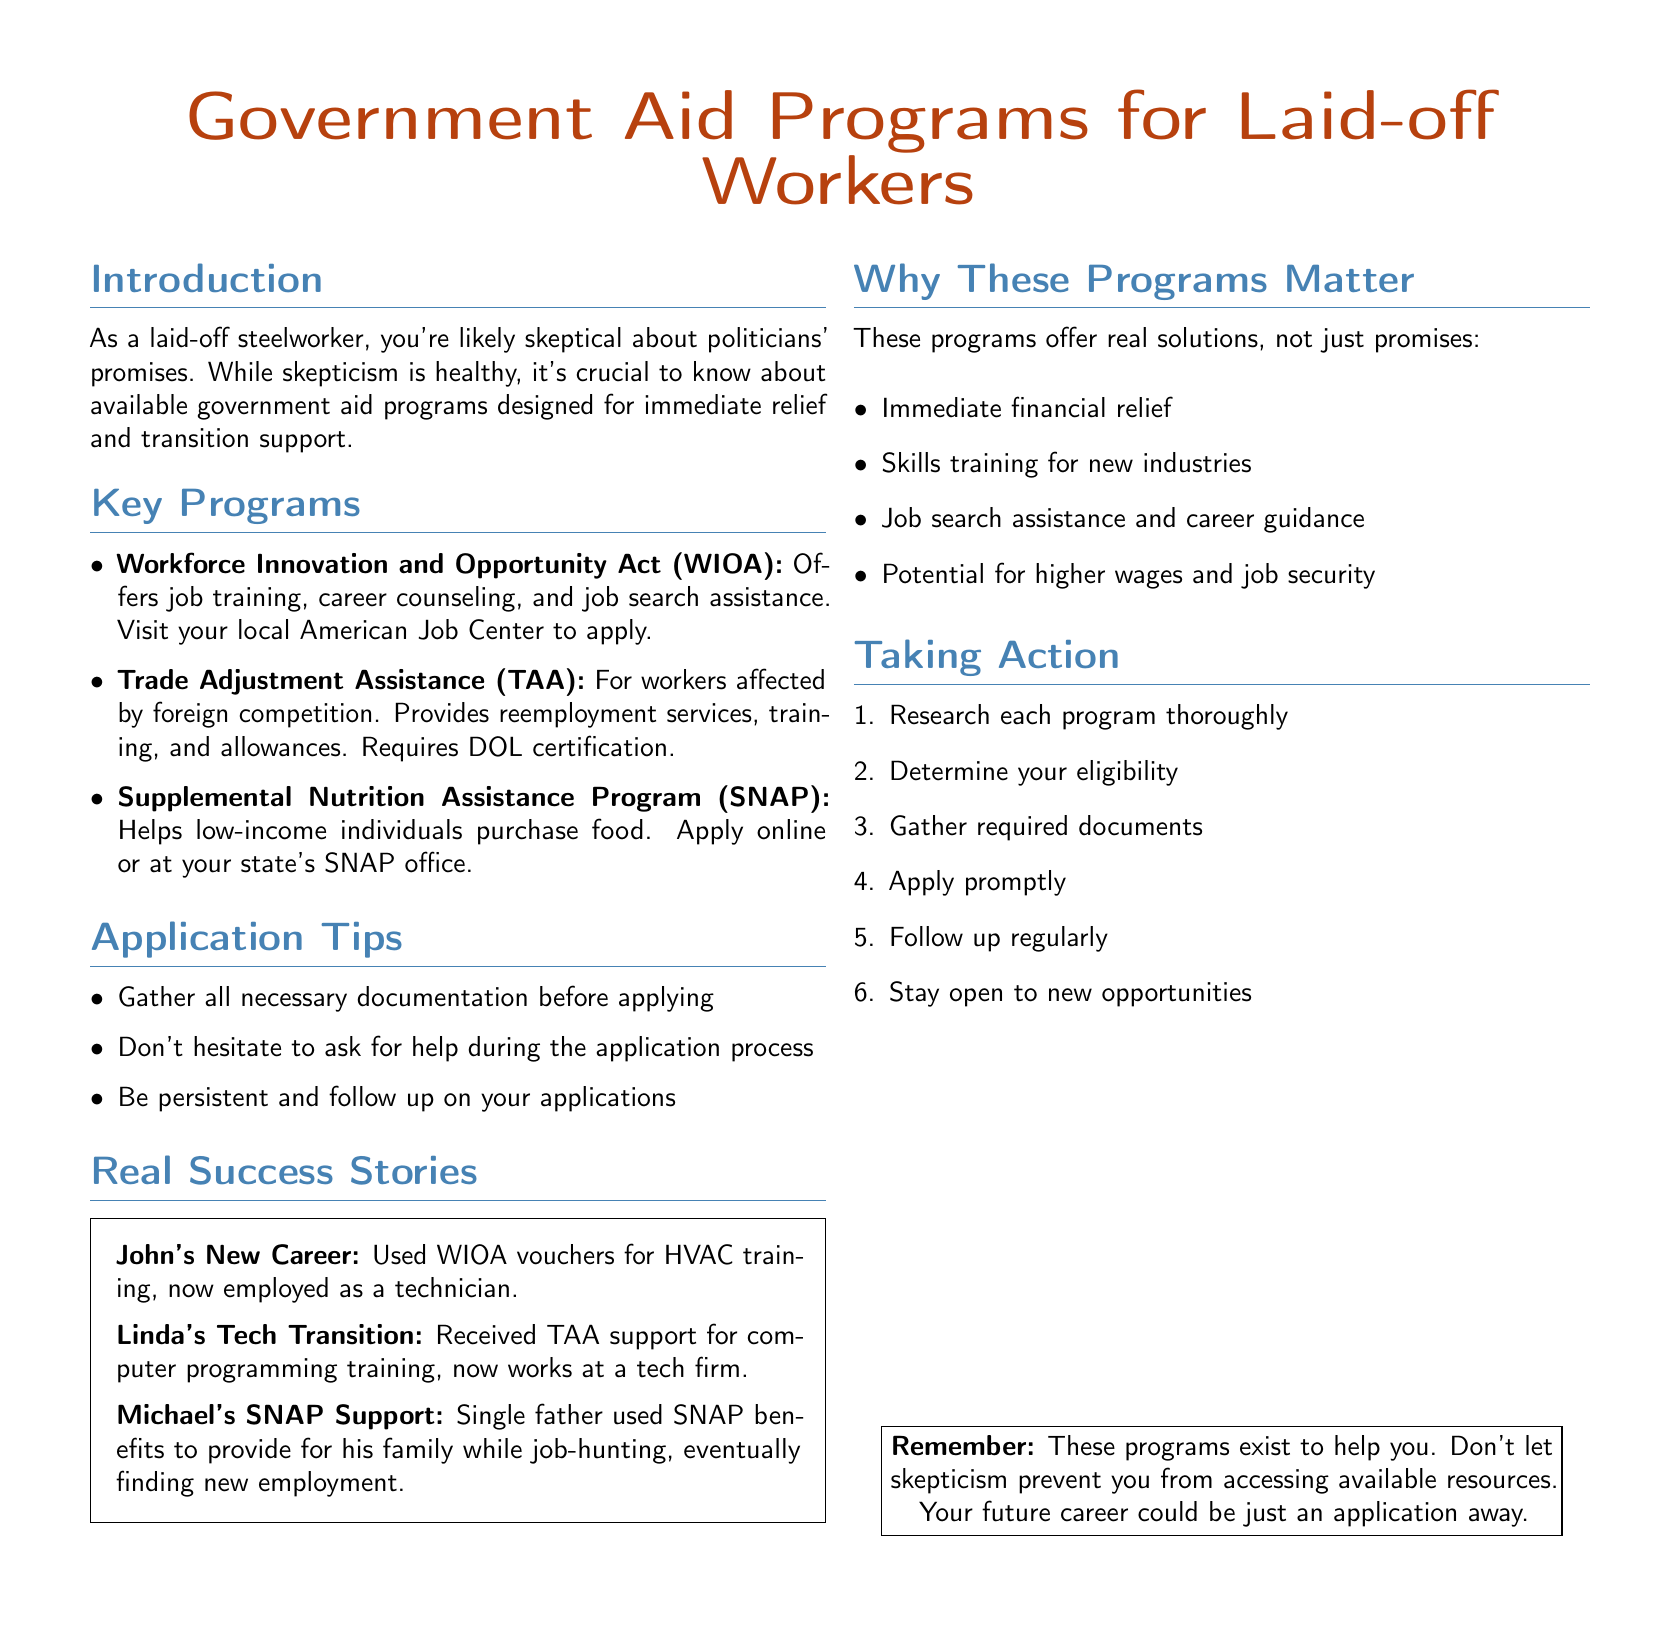What is the main purpose of government aid programs? The main purpose of government aid programs is to provide immediate relief and transition support for laid-off workers.
Answer: Immediate relief and transition support What is the first program listed for aid? The first program listed is the Workforce Innovation and Opportunity Act (WIOA).
Answer: Workforce Innovation and Opportunity Act (WIOA) What does the Trade Adjustment Assistance (TAA) program provide? The TAA program provides reemployment services, training, and allowances for workers affected by foreign competition.
Answer: Reemployment services, training, and allowances What is one tip given for the application process? One tip given is to gather all necessary documentation before applying.
Answer: Gather all necessary documentation How many success stories are mentioned in the document? Three success stories are mentioned in the document.
Answer: Three Which program helps with food purchases for low-income individuals? The program that helps with food purchases is the Supplemental Nutrition Assistance Program (SNAP).
Answer: Supplemental Nutrition Assistance Program (SNAP) What actionable steps are suggested in the "Taking Action" section? The actionable steps include researching programs, determining eligibility, gathering documents, applying, following up, and staying open to new opportunities.
Answer: Researching programs, determining eligibility, gathering documents, applying, following up, staying open What is one reason why these programs matter? One reason why these programs matter is that they provide immediate financial relief.
Answer: Immediate financial relief What advice is given for remaining skeptical about the programs? The advice given is not to let skepticism prevent access to available resources.
Answer: Don't let skepticism prevent access 